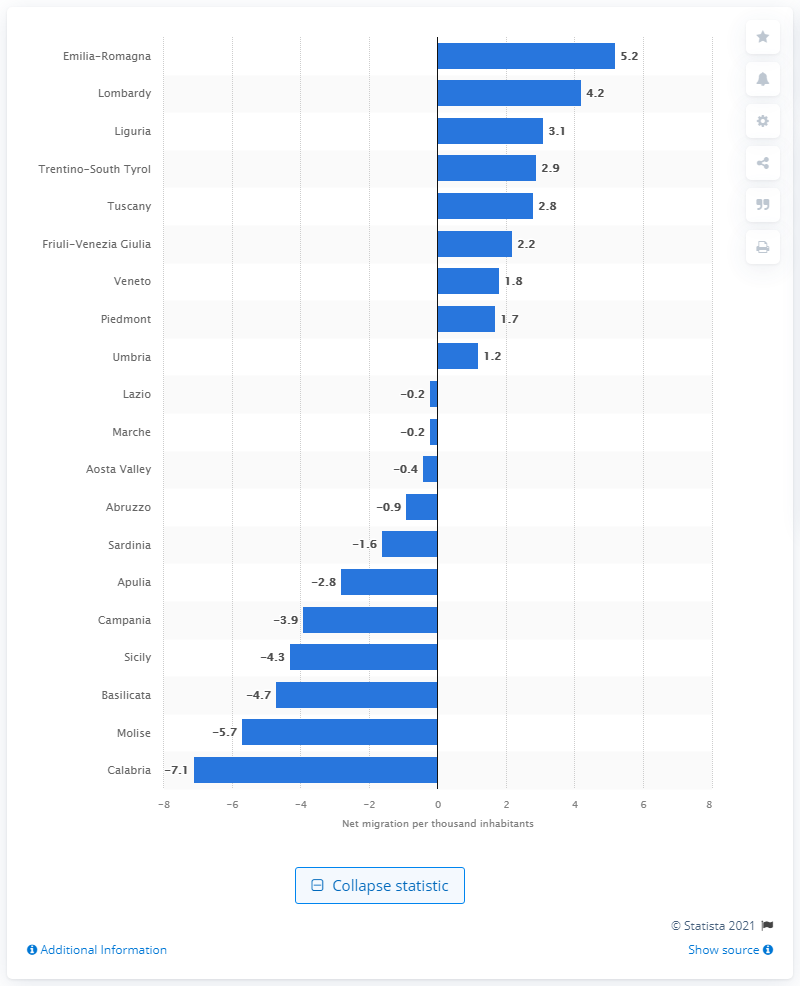Specify some key components in this picture. In 2019, Emilia-Romagna had the largest increase in inhabitants among all regions in Italy. 